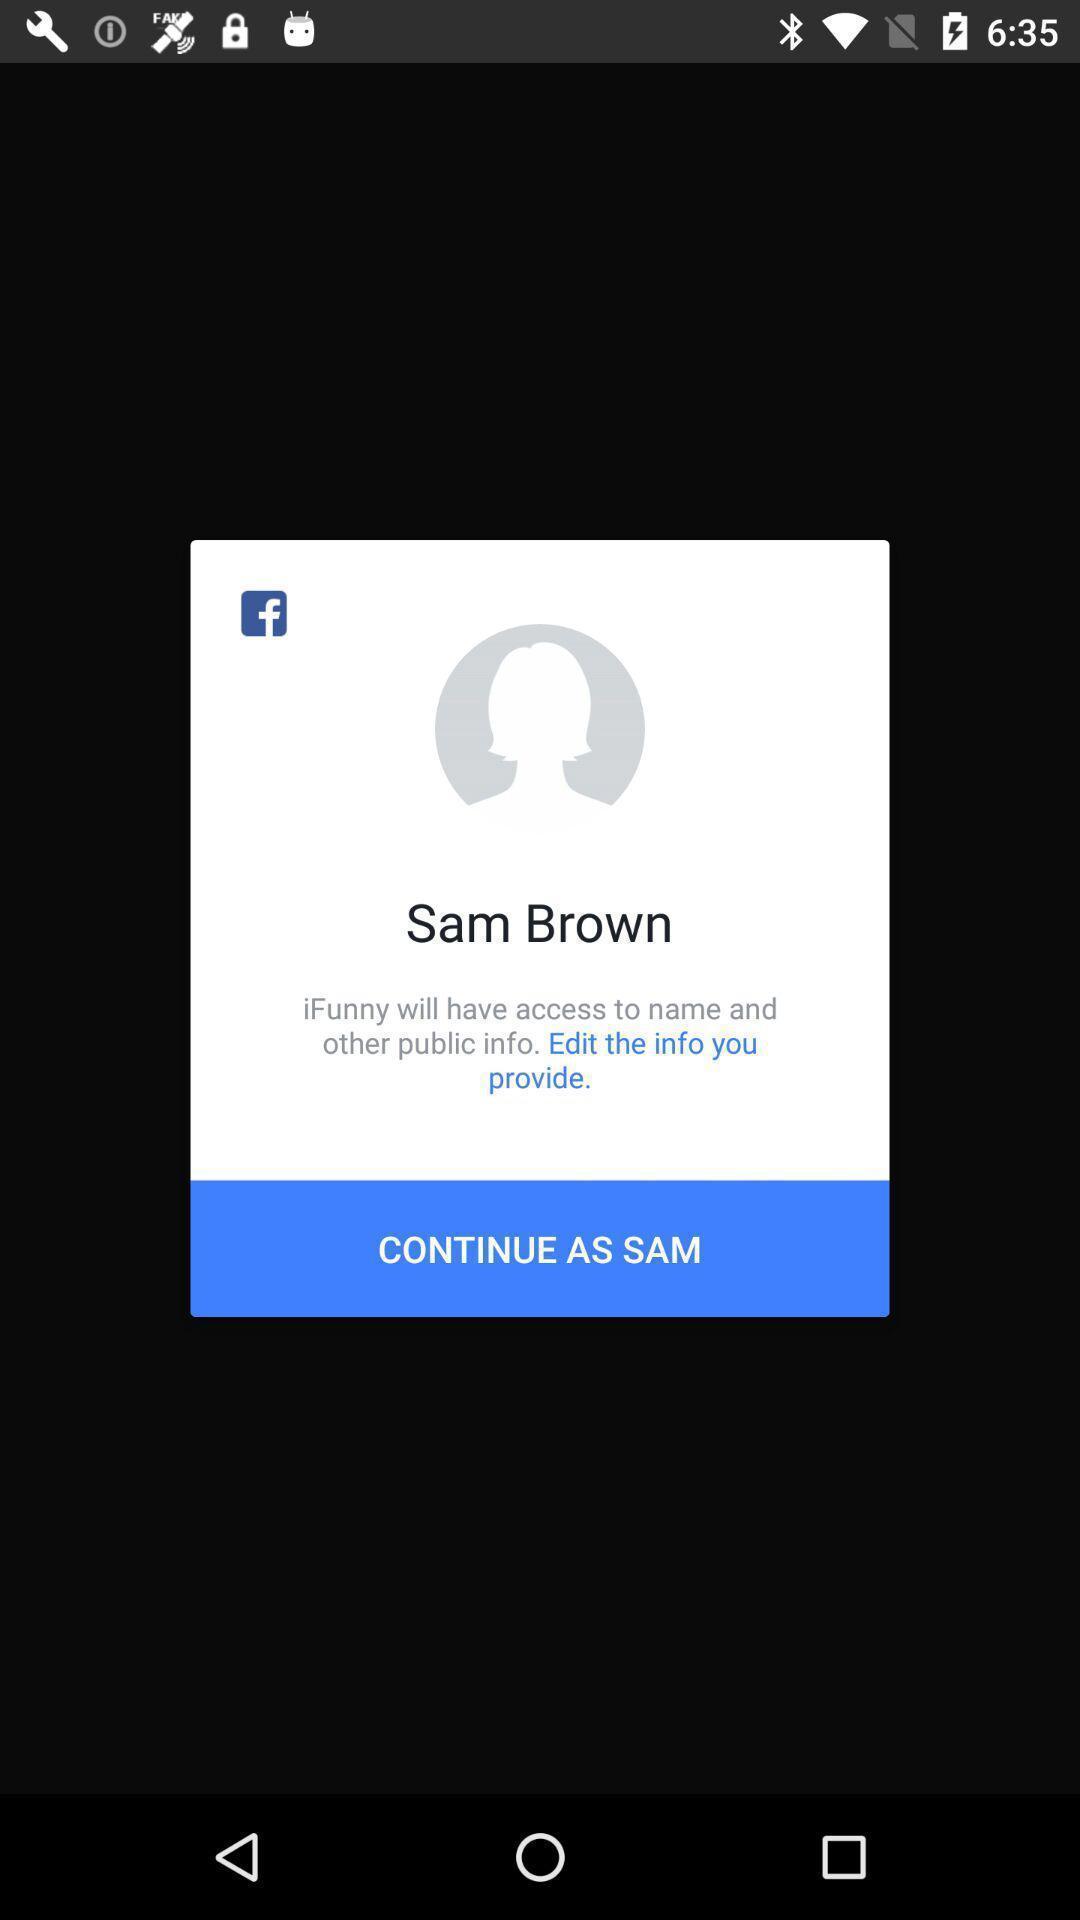Explain what's happening in this screen capture. Pop up window of profile. 